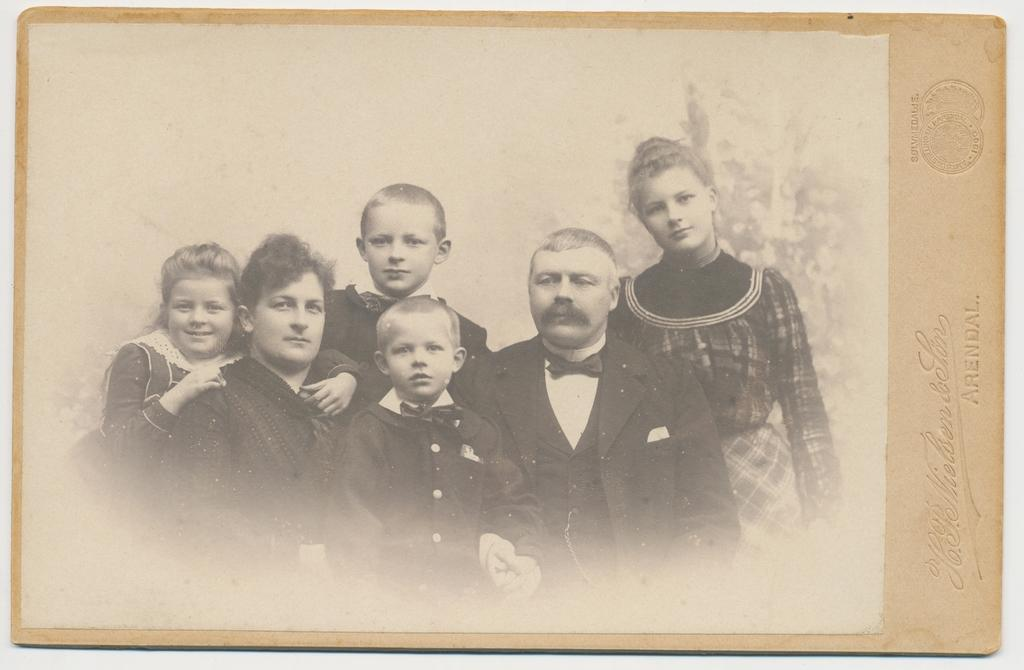What is hanging on the wall in the image? There is a photo frame on the wall. What is inside the photo frame? The photo frame contains a photograph. Who or what can be seen in the photograph? There are people in the photograph. Are there any additional details on the photo frame? Yes, there is some text on the photo frame. Is there any other marking on the photo frame? Yes, there is a watermark on the photo frame. How many sticks are used to hold the bead in the image? There are no sticks or beads present in the image. What is the level of the water in the image? There is no water or level mentioned in the image. 